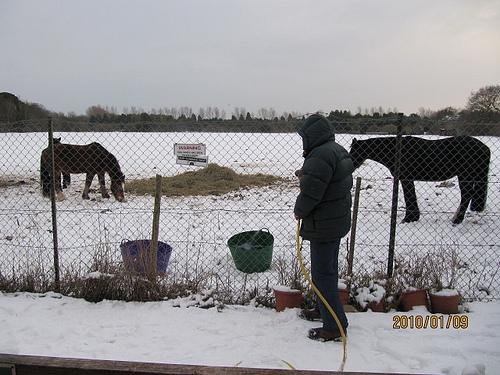What animals are in the picture?
Keep it brief. Horses. What month was the photo taken in?
Be succinct. January. Who put out the hay?
Short answer required. Man. Are there lots of snow on the ground?
Concise answer only. Yes. 